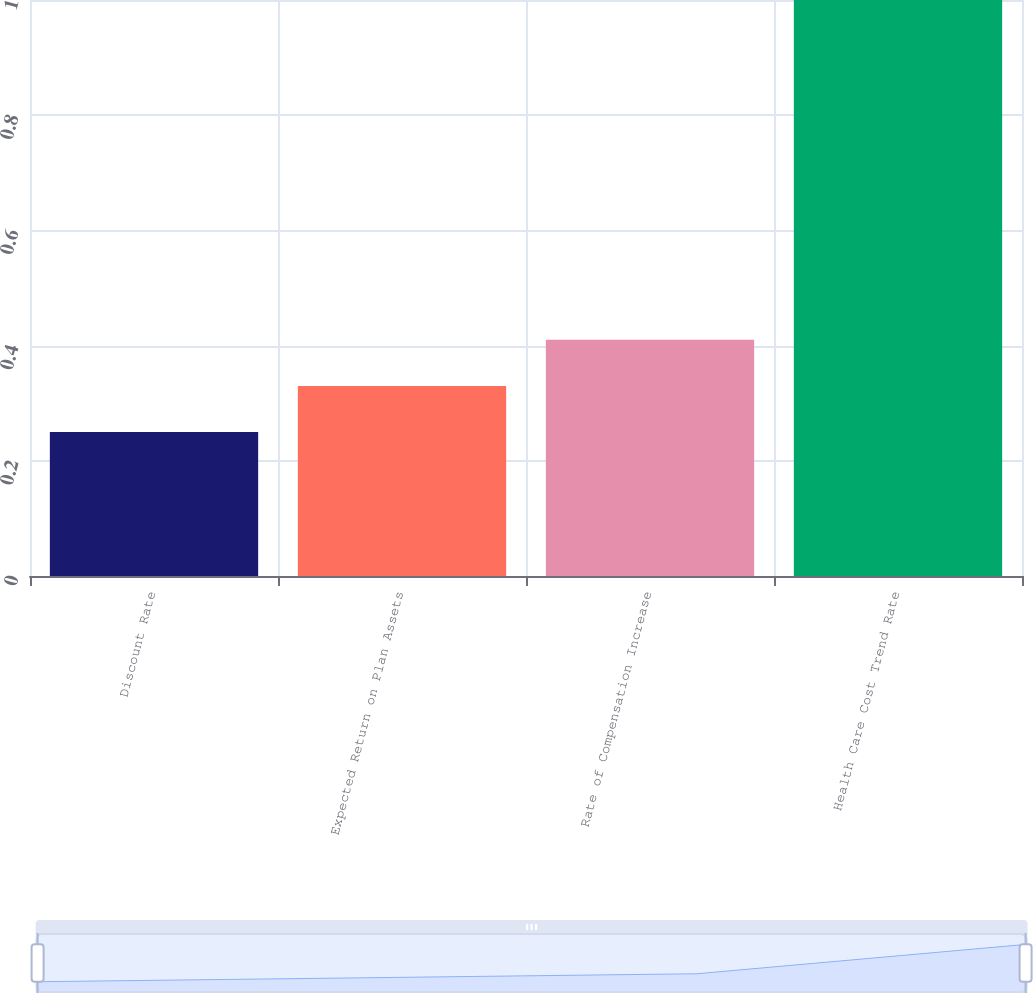Convert chart. <chart><loc_0><loc_0><loc_500><loc_500><bar_chart><fcel>Discount Rate<fcel>Expected Return on Plan Assets<fcel>Rate of Compensation Increase<fcel>Health Care Cost Trend Rate<nl><fcel>0.25<fcel>0.33<fcel>0.41<fcel>1<nl></chart> 